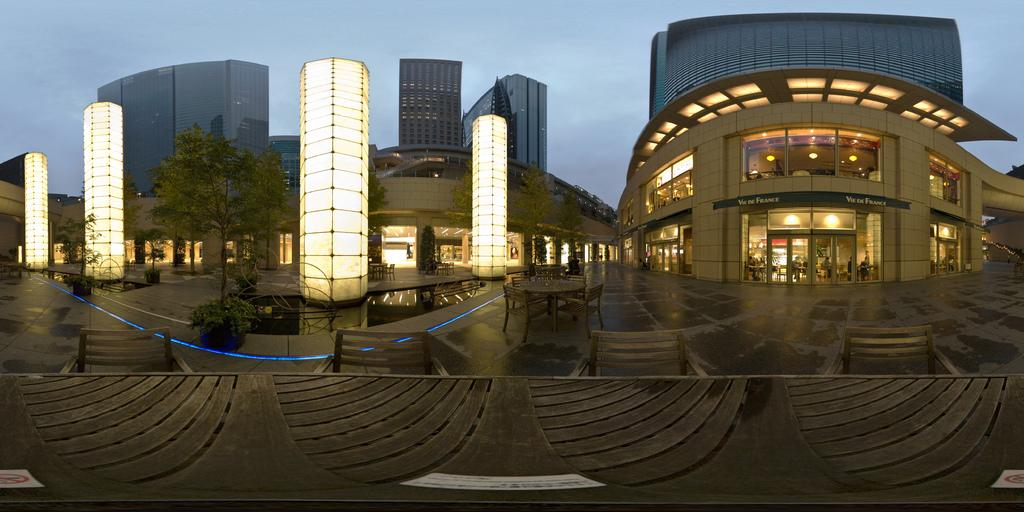What type of structures can be seen in the image? There are buildings in the image. What architectural features are present on the buildings? There are windows and doors visible on the buildings. What type of illumination is present in the image? There are lights in the image. What type of seating is available in the image? There are benches and chairs in the image. What type of vegetation is present in the image? There are trees and plants in the image. What natural element is visible in the image? There is water visible in the image. What part of the natural environment is visible in the image? The sky is visible in the image. How many nails can be seen in the image? There are no nails present in the image. 